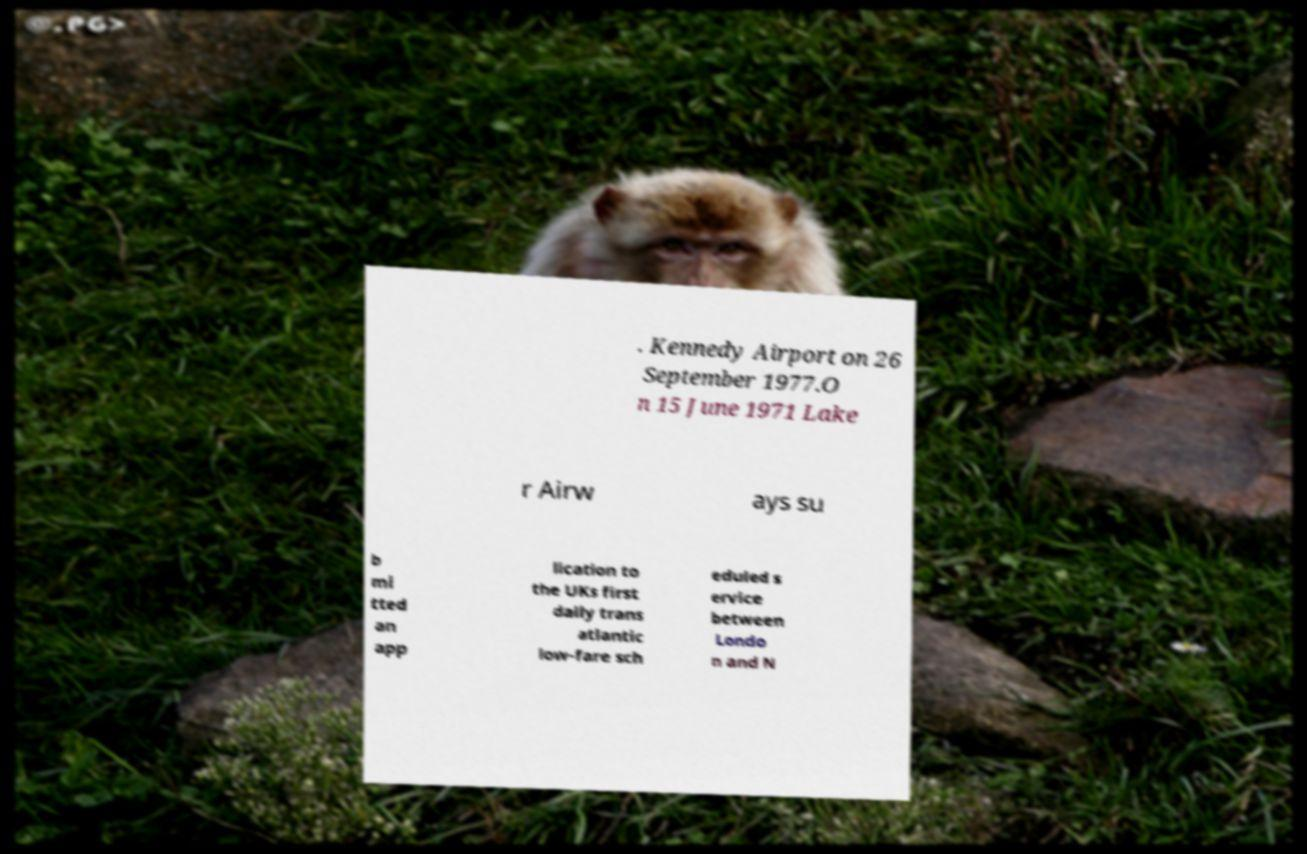Could you assist in decoding the text presented in this image and type it out clearly? . Kennedy Airport on 26 September 1977.O n 15 June 1971 Lake r Airw ays su b mi tted an app lication to the UKs first daily trans atlantic low-fare sch eduled s ervice between Londo n and N 